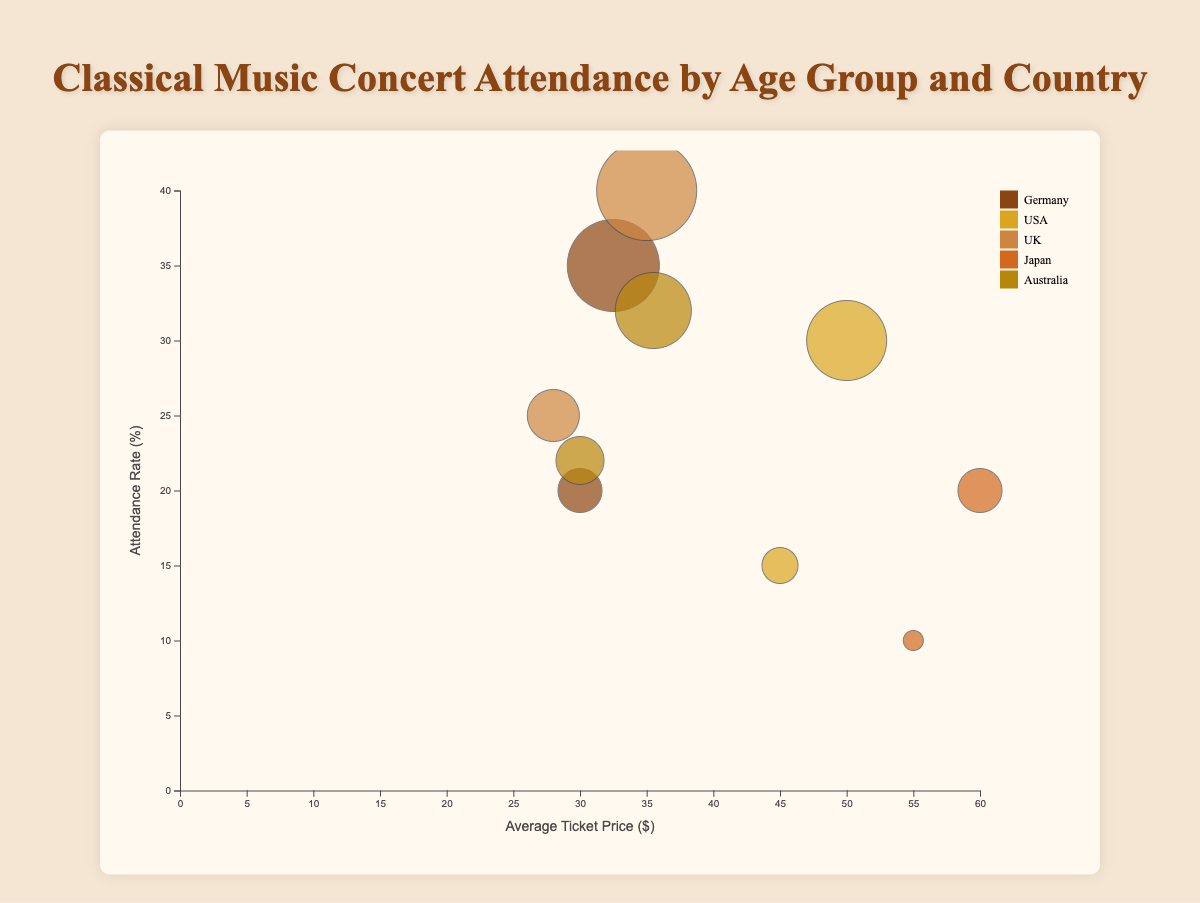What is the title of the chart? The title of the chart is located at the top and provides a brief description of what the chart illustrates.
Answer: Classical Music Concert Attendance by Age Group and Country Which country has the highest attendance rate for the age group 18-24? To determine this, locate the bubbles associated with the 18-24 age group and compare their positions on the y-axis, which represents the attendance rate.
Answer: UK What is the average ticket price for concerts in Japan for the 25-34 age group? Identify the bubble representing Japan for the 25-34 age group, follow it to the x-axis to find the average ticket price.
Answer: $60.00 Which country has the largest attendance rate difference between the age groups 18-24 and 25-34? Calculate the absolute attendance rate difference for both age groups for each country and compare to find the maximum difference. For Germany: 35-20=15%, USA: 30-15=15%, UK: 40-25=15%, Japan: 20-10=10%, Australia: 32-22=10%.
Answer: Germany, USA, UK (tie) Rank the countries based on the average ticket price for the 18-24 age group, from highest to lowest. Identify the bubbles for the 18-24 age group for each country, follow them to the x-axis, and list them in descending order of average ticket price.
Answer: Japan, USA, UK, Australia, Germany Which age group attends the most concerts in the UK? Look at the size of the bubbles for the UK and compare their radii, which correlate with the total concerts attended.
Answer: 25-34 Between Germany and Australia, which country has a higher average ticket price for the 25-34 age group? Compare the x-axis positions of the 25-34 age group bubbles for both Germany and Australia.
Answer: Australia What is the average attendance rate for the 18-24 age group across all countries? Sum up the attendance rates for the 18-24 age group from all countries and divide by the number of countries: (20 + 15 + 25 + 10 + 22) / 5 = 18.4%.
Answer: 18.4% Which bubble represents the highest attendance rate, and which country and age group does it belong to? Identify the bubble positioned highest on the y-axis and note the corresponding country and age group.
Answer: UK, 25-34 What is the relationship between the average ticket price and attendance rate for Germany? Look at the bubbles corresponding to Germany and observe the correlation between their x-axis (ticket price) and y-axis (attendance rate) positions. Higher prices tend to be associated with higher attendance rates for Germany.
Answer: Positive correlation 